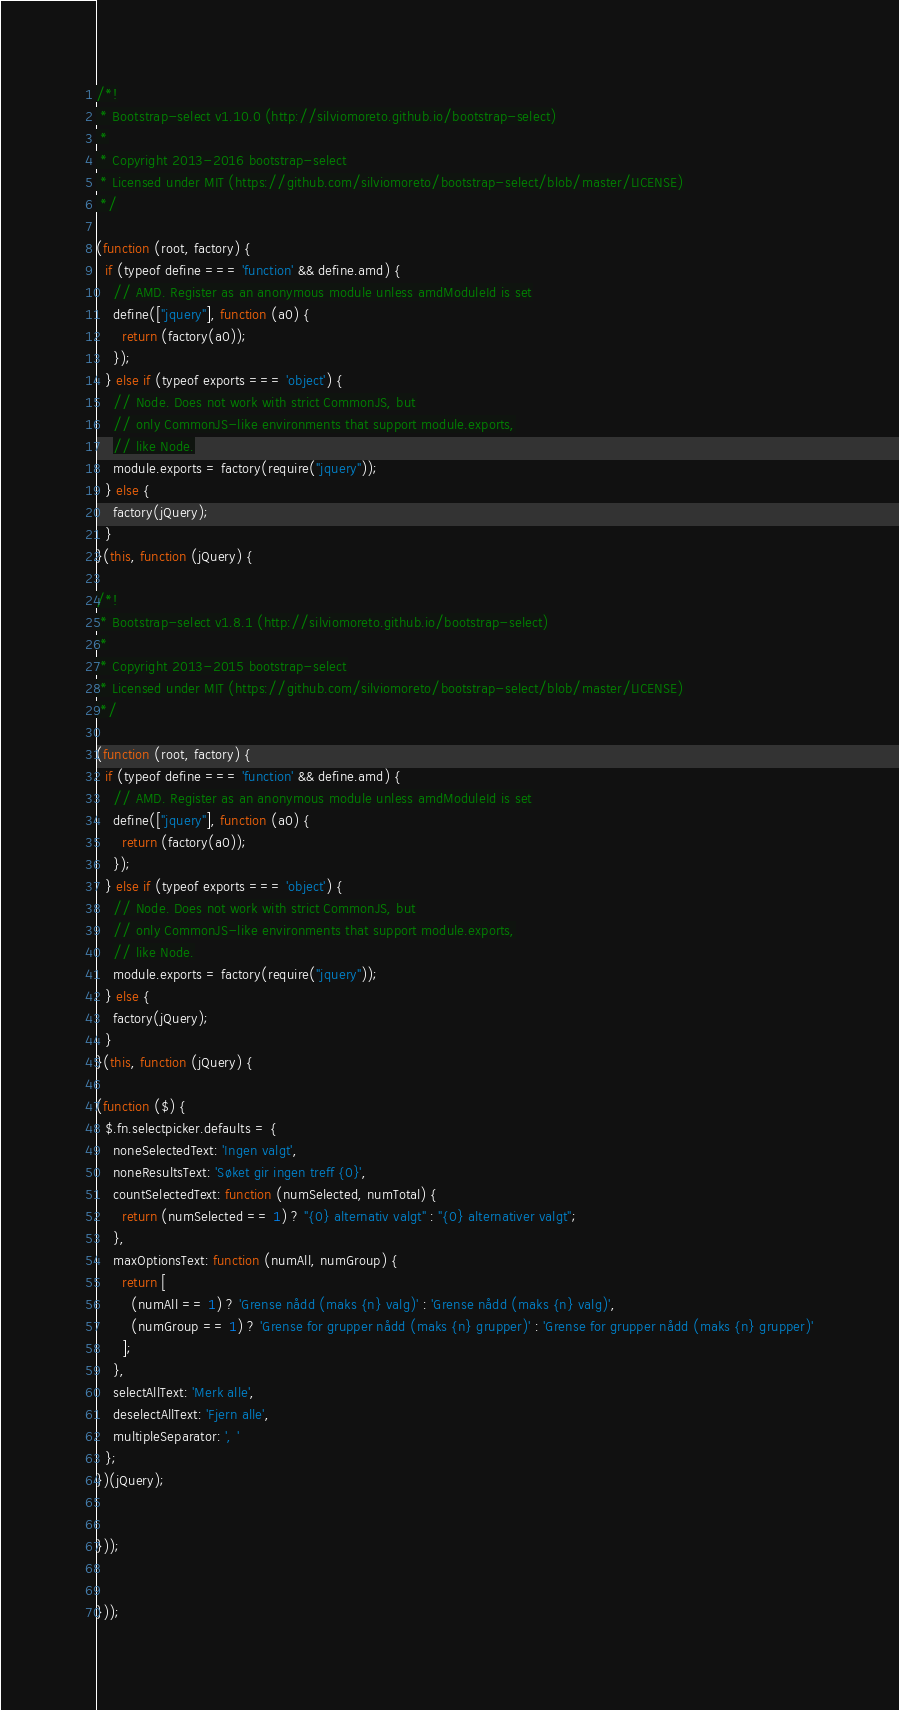<code> <loc_0><loc_0><loc_500><loc_500><_JavaScript_>/*!
 * Bootstrap-select v1.10.0 (http://silviomoreto.github.io/bootstrap-select)
 *
 * Copyright 2013-2016 bootstrap-select
 * Licensed under MIT (https://github.com/silviomoreto/bootstrap-select/blob/master/LICENSE)
 */

(function (root, factory) {
  if (typeof define === 'function' && define.amd) {
    // AMD. Register as an anonymous module unless amdModuleId is set
    define(["jquery"], function (a0) {
      return (factory(a0));
    });
  } else if (typeof exports === 'object') {
    // Node. Does not work with strict CommonJS, but
    // only CommonJS-like environments that support module.exports,
    // like Node.
    module.exports = factory(require("jquery"));
  } else {
    factory(jQuery);
  }
}(this, function (jQuery) {

/*!
 * Bootstrap-select v1.8.1 (http://silviomoreto.github.io/bootstrap-select)
 *
 * Copyright 2013-2015 bootstrap-select
 * Licensed under MIT (https://github.com/silviomoreto/bootstrap-select/blob/master/LICENSE)
 */

(function (root, factory) {
  if (typeof define === 'function' && define.amd) {
    // AMD. Register as an anonymous module unless amdModuleId is set
    define(["jquery"], function (a0) {
      return (factory(a0));
    });
  } else if (typeof exports === 'object') {
    // Node. Does not work with strict CommonJS, but
    // only CommonJS-like environments that support module.exports,
    // like Node.
    module.exports = factory(require("jquery"));
  } else {
    factory(jQuery);
  }
}(this, function (jQuery) {

(function ($) {
  $.fn.selectpicker.defaults = {
    noneSelectedText: 'Ingen valgt',
    noneResultsText: 'Søket gir ingen treff {0}',
    countSelectedText: function (numSelected, numTotal) {
      return (numSelected == 1) ? "{0} alternativ valgt" : "{0} alternativer valgt";
    },
    maxOptionsText: function (numAll, numGroup) {
      return [
        (numAll == 1) ? 'Grense nådd (maks {n} valg)' : 'Grense nådd (maks {n} valg)',
        (numGroup == 1) ? 'Grense for grupper nådd (maks {n} grupper)' : 'Grense for grupper nådd (maks {n} grupper)'
      ];
    },
    selectAllText: 'Merk alle',
    deselectAllText: 'Fjern alle',
    multipleSeparator: ', '
  };
})(jQuery);


}));


}));
</code> 